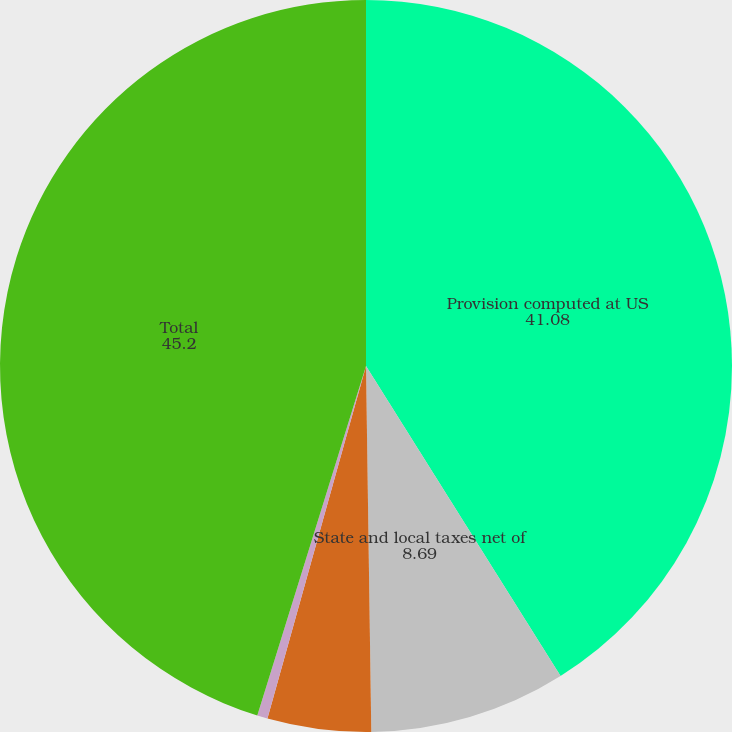Convert chart. <chart><loc_0><loc_0><loc_500><loc_500><pie_chart><fcel>Provision computed at US<fcel>State and local taxes net of<fcel>Domestic manufacturers<fcel>Other<fcel>Total<nl><fcel>41.08%<fcel>8.69%<fcel>4.57%<fcel>0.46%<fcel>45.2%<nl></chart> 